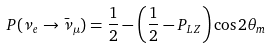Convert formula to latex. <formula><loc_0><loc_0><loc_500><loc_500>P ( \nu _ { e } \to \bar { \nu } _ { \mu } ) = \frac { 1 } { 2 } - \left ( \frac { 1 } { 2 } - P _ { L Z } \right ) \cos 2 \theta _ { m }</formula> 